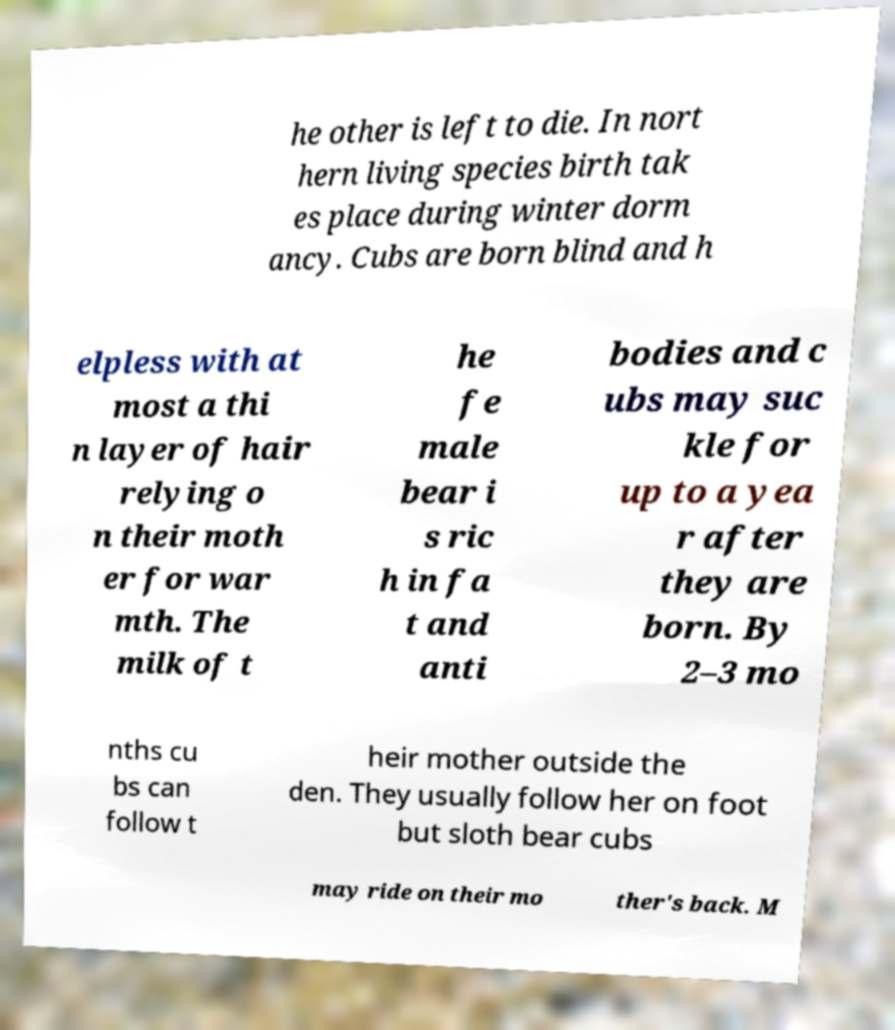Can you read and provide the text displayed in the image?This photo seems to have some interesting text. Can you extract and type it out for me? he other is left to die. In nort hern living species birth tak es place during winter dorm ancy. Cubs are born blind and h elpless with at most a thi n layer of hair relying o n their moth er for war mth. The milk of t he fe male bear i s ric h in fa t and anti bodies and c ubs may suc kle for up to a yea r after they are born. By 2–3 mo nths cu bs can follow t heir mother outside the den. They usually follow her on foot but sloth bear cubs may ride on their mo ther's back. M 